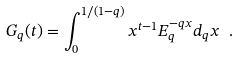Convert formula to latex. <formula><loc_0><loc_0><loc_500><loc_500>\ G _ { q } ( t ) = \int _ { 0 } ^ { 1 / ( 1 - q ) } x ^ { t - 1 } E _ { q } ^ { - q x } d _ { q } x \ .</formula> 